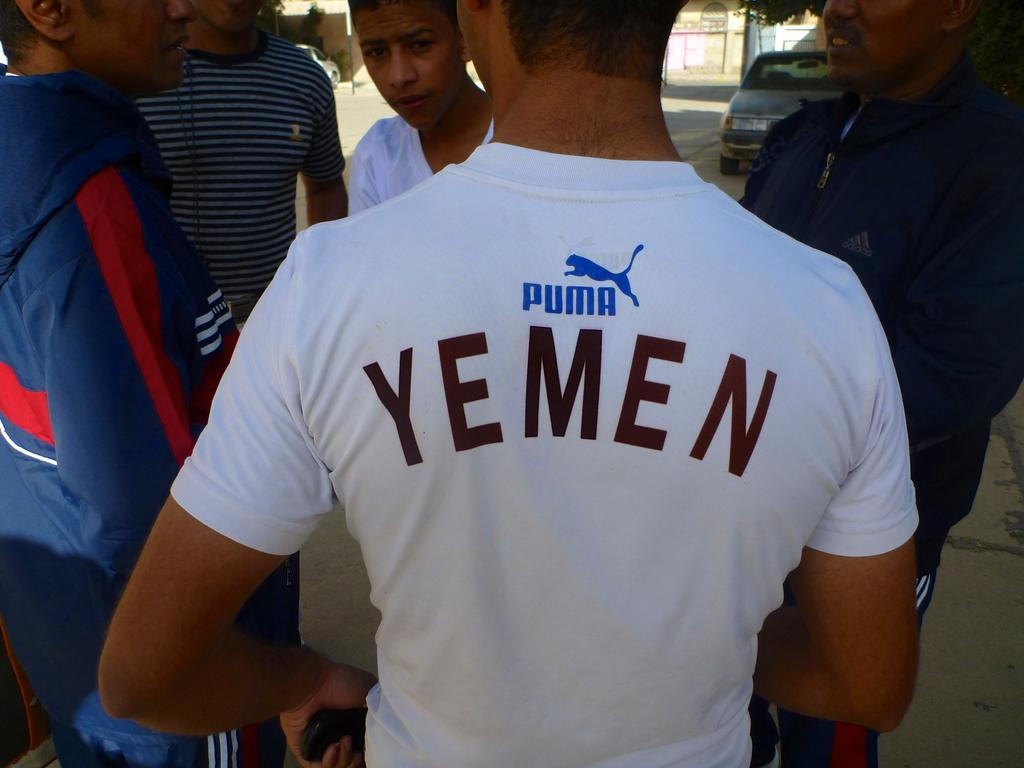<image>
Offer a succinct explanation of the picture presented. A white t-shirt has a logo for Puma on the back in blue. 